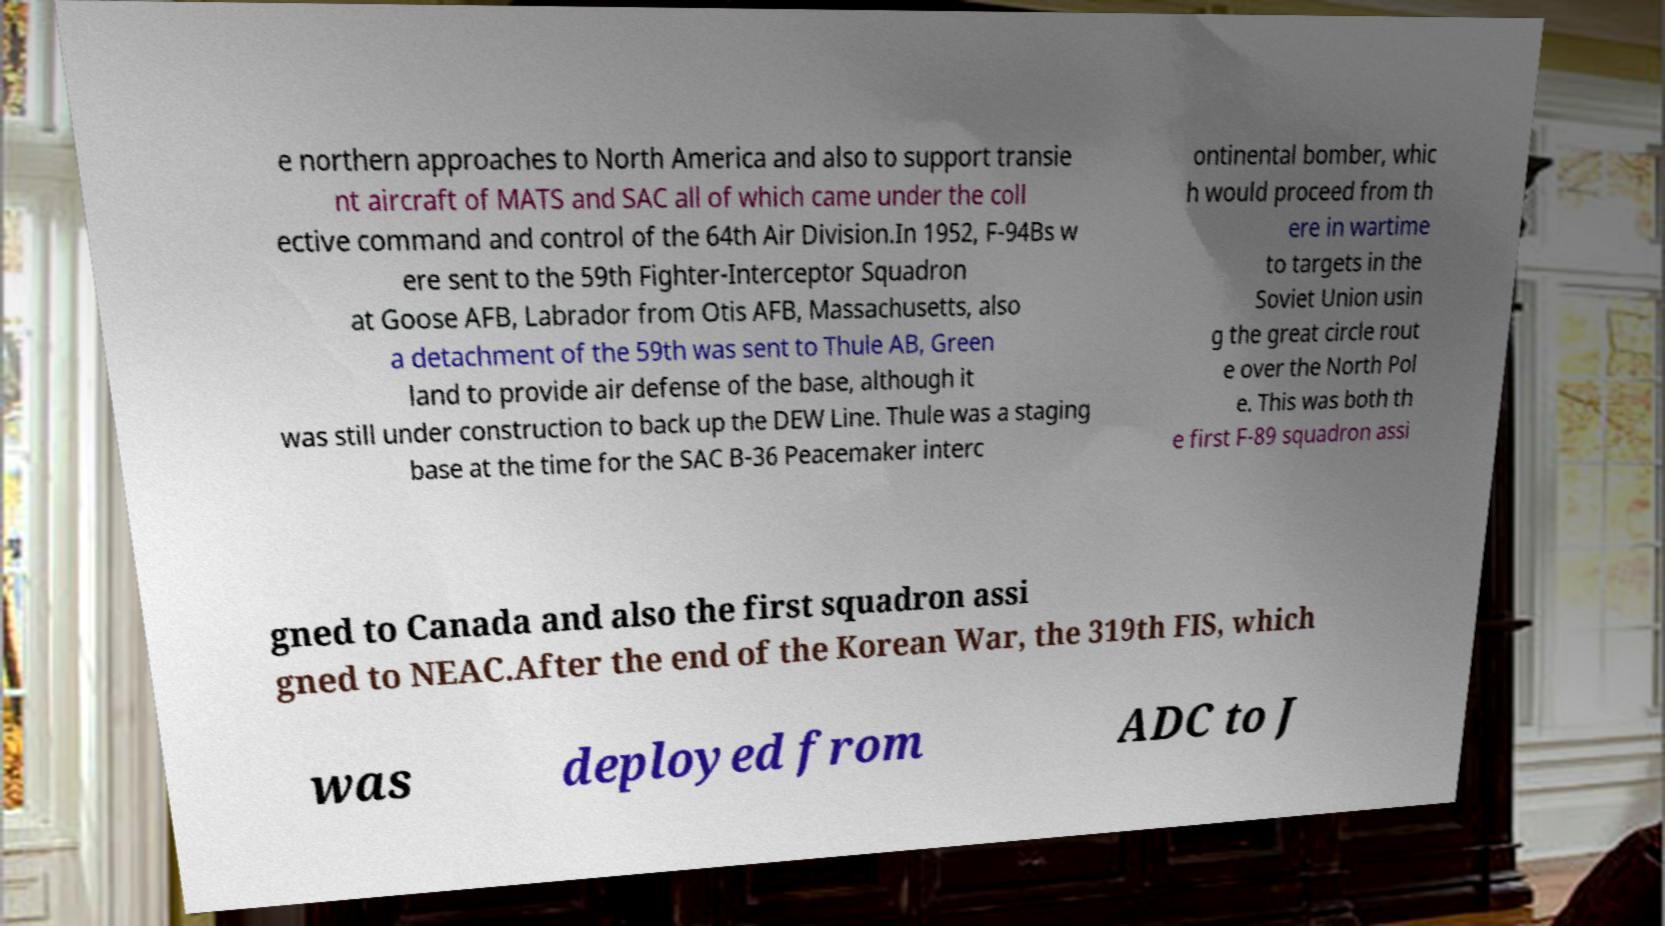What messages or text are displayed in this image? I need them in a readable, typed format. e northern approaches to North America and also to support transie nt aircraft of MATS and SAC all of which came under the coll ective command and control of the 64th Air Division.In 1952, F-94Bs w ere sent to the 59th Fighter-Interceptor Squadron at Goose AFB, Labrador from Otis AFB, Massachusetts, also a detachment of the 59th was sent to Thule AB, Green land to provide air defense of the base, although it was still under construction to back up the DEW Line. Thule was a staging base at the time for the SAC B-36 Peacemaker interc ontinental bomber, whic h would proceed from th ere in wartime to targets in the Soviet Union usin g the great circle rout e over the North Pol e. This was both th e first F-89 squadron assi gned to Canada and also the first squadron assi gned to NEAC.After the end of the Korean War, the 319th FIS, which was deployed from ADC to J 